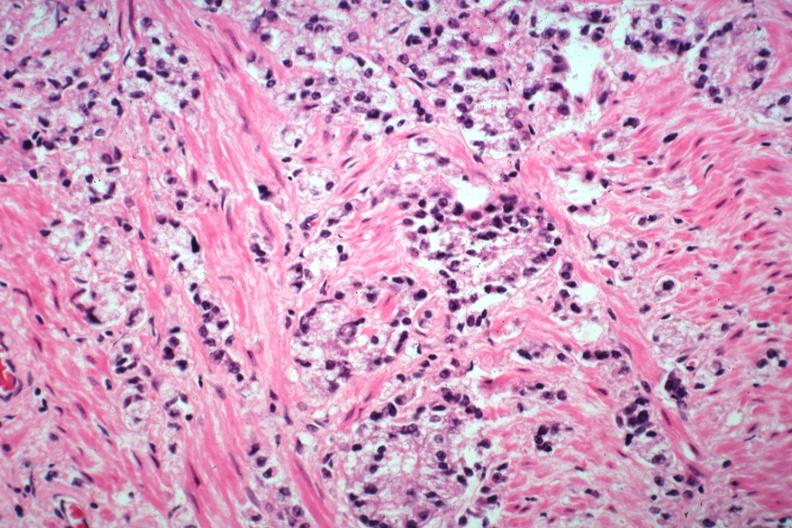what does this image show?
Answer the question using a single word or phrase. Typical infiltrating prostate carcinoma 